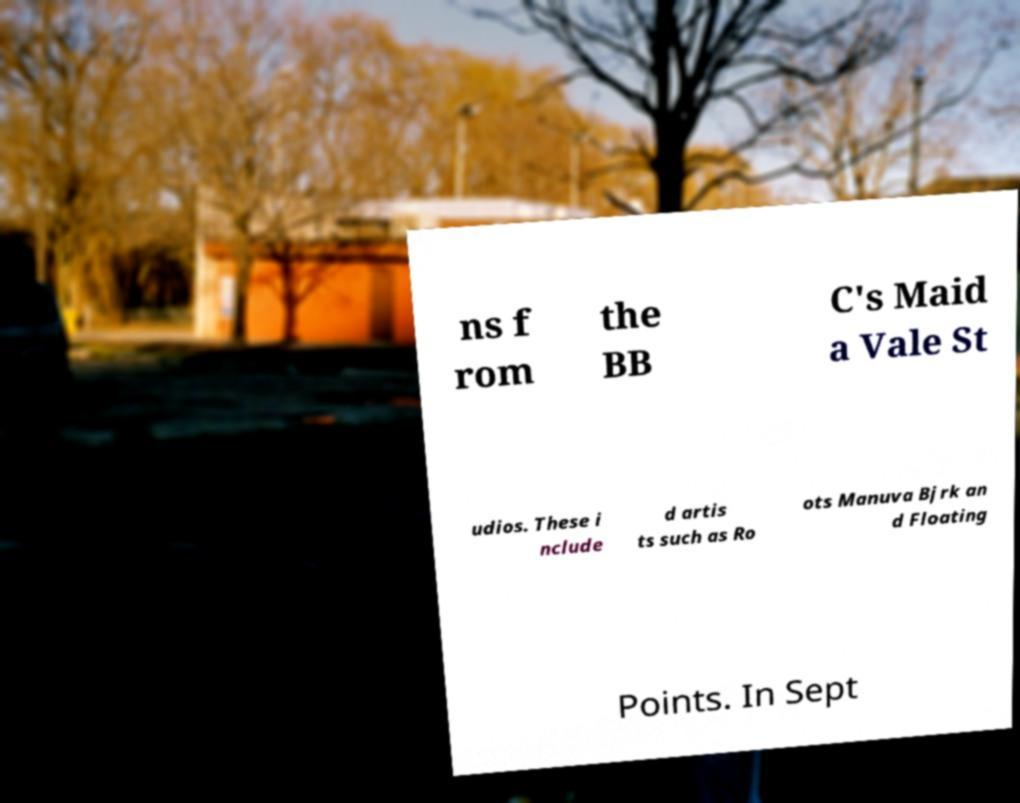Can you read and provide the text displayed in the image?This photo seems to have some interesting text. Can you extract and type it out for me? ns f rom the BB C's Maid a Vale St udios. These i nclude d artis ts such as Ro ots Manuva Bjrk an d Floating Points. In Sept 